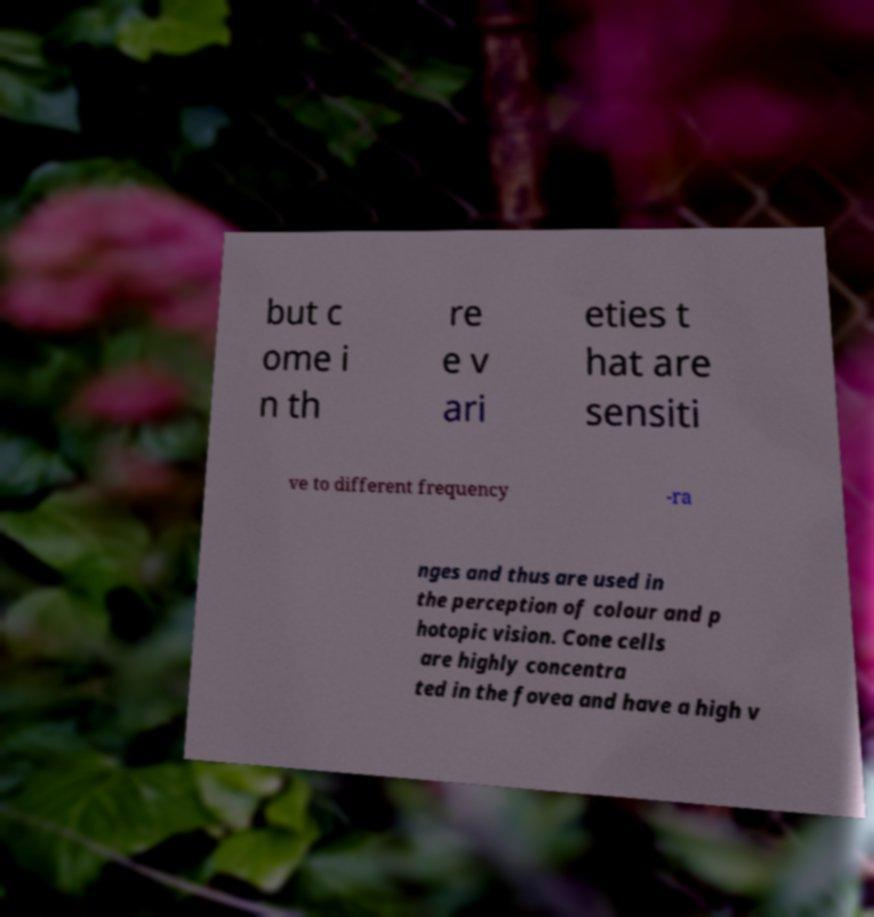Please identify and transcribe the text found in this image. but c ome i n th re e v ari eties t hat are sensiti ve to different frequency -ra nges and thus are used in the perception of colour and p hotopic vision. Cone cells are highly concentra ted in the fovea and have a high v 